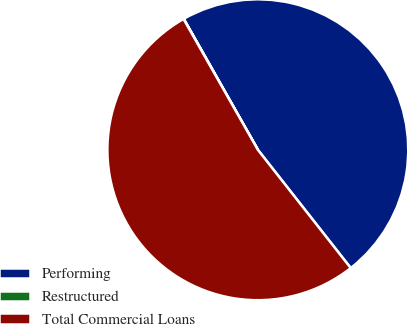<chart> <loc_0><loc_0><loc_500><loc_500><pie_chart><fcel>Performing<fcel>Restructured<fcel>Total Commercial Loans<nl><fcel>47.6%<fcel>0.03%<fcel>52.37%<nl></chart> 